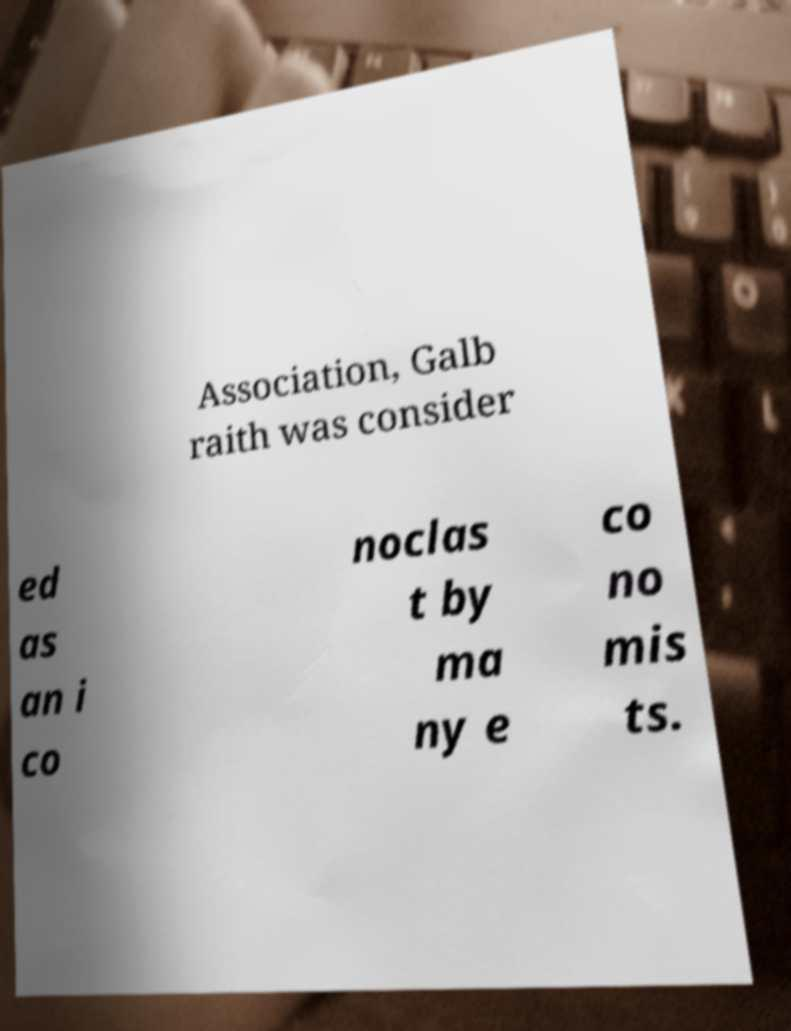Please identify and transcribe the text found in this image. Association, Galb raith was consider ed as an i co noclas t by ma ny e co no mis ts. 